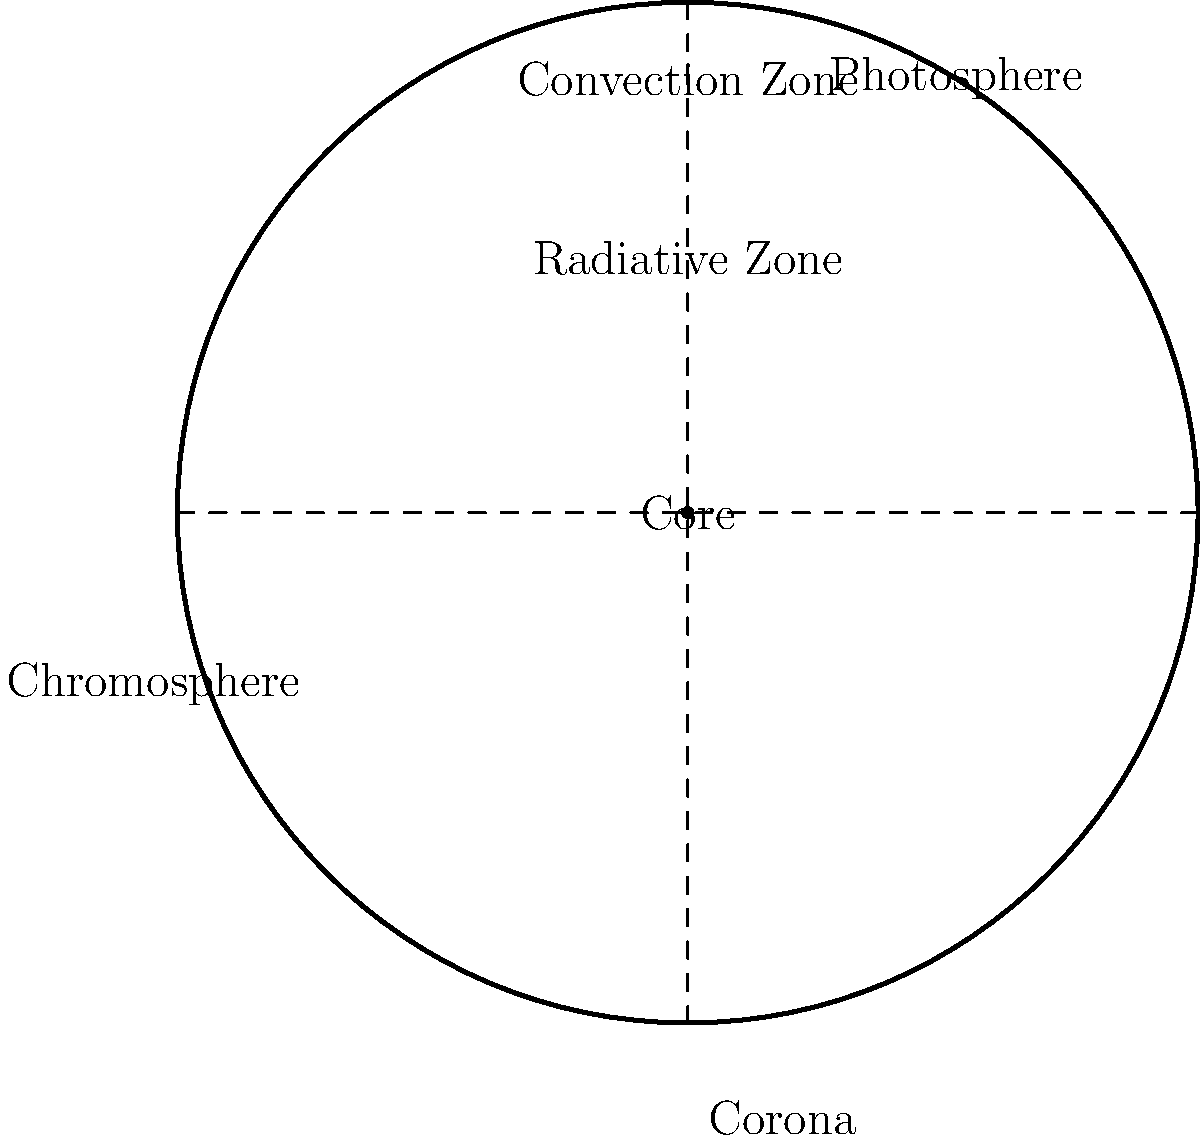In your years of dancing tango, you've experienced the importance of layers in both music and movement. Similarly, the Sun has distinct layers that contribute to its overall structure. Looking at this cross-sectional diagram of the Sun, which layer is responsible for the visible surface we see from Earth? To answer this question, let's examine the layers of the Sun from the inside out:

1. Core: The innermost layer where nuclear fusion occurs.
2. Radiative Zone: The layer surrounding the core where energy is transferred through radiation.
3. Convection Zone: The layer where energy is transferred through convection currents.
4. Photosphere: This is the visible surface of the Sun that we can see from Earth.
5. Chromosphere: A thin layer above the photosphere, visible during solar eclipses.
6. Corona: The outermost layer of the Sun's atmosphere, extending far into space.

The layer responsible for the visible surface we see from Earth is the photosphere. This layer is often referred to as the Sun's "surface" because it's the deepest layer we can directly observe. The photosphere is relatively thin (about 500 km thick) compared to the Sun's radius (about 696,000 km).

Just as in tango, where the visible movements are a result of the underlying structure and technique, the photosphere is the visible manifestation of the complex processes occurring in the Sun's interior layers.
Answer: Photosphere 